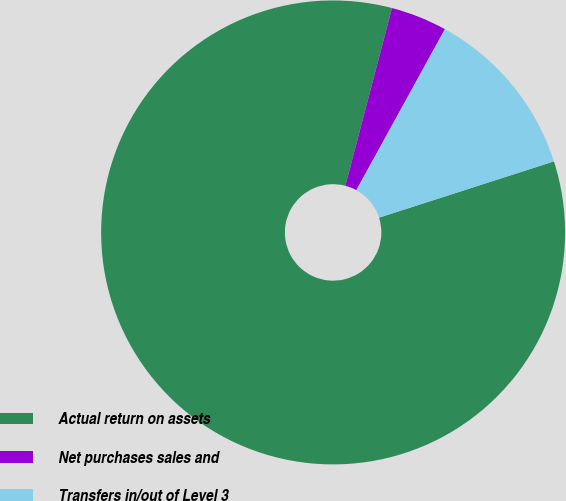Convert chart to OTSL. <chart><loc_0><loc_0><loc_500><loc_500><pie_chart><fcel>Actual return on assets<fcel>Net purchases sales and<fcel>Transfers in/out of Level 3<nl><fcel>84.03%<fcel>3.92%<fcel>12.04%<nl></chart> 